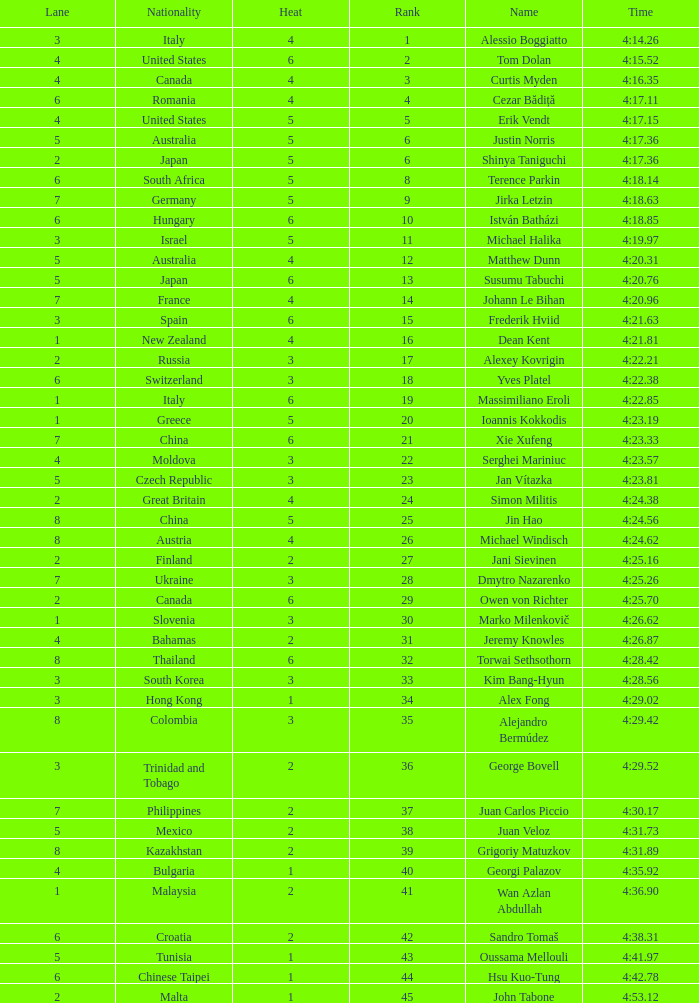Who was the 4 lane person from Canada? 4.0. 